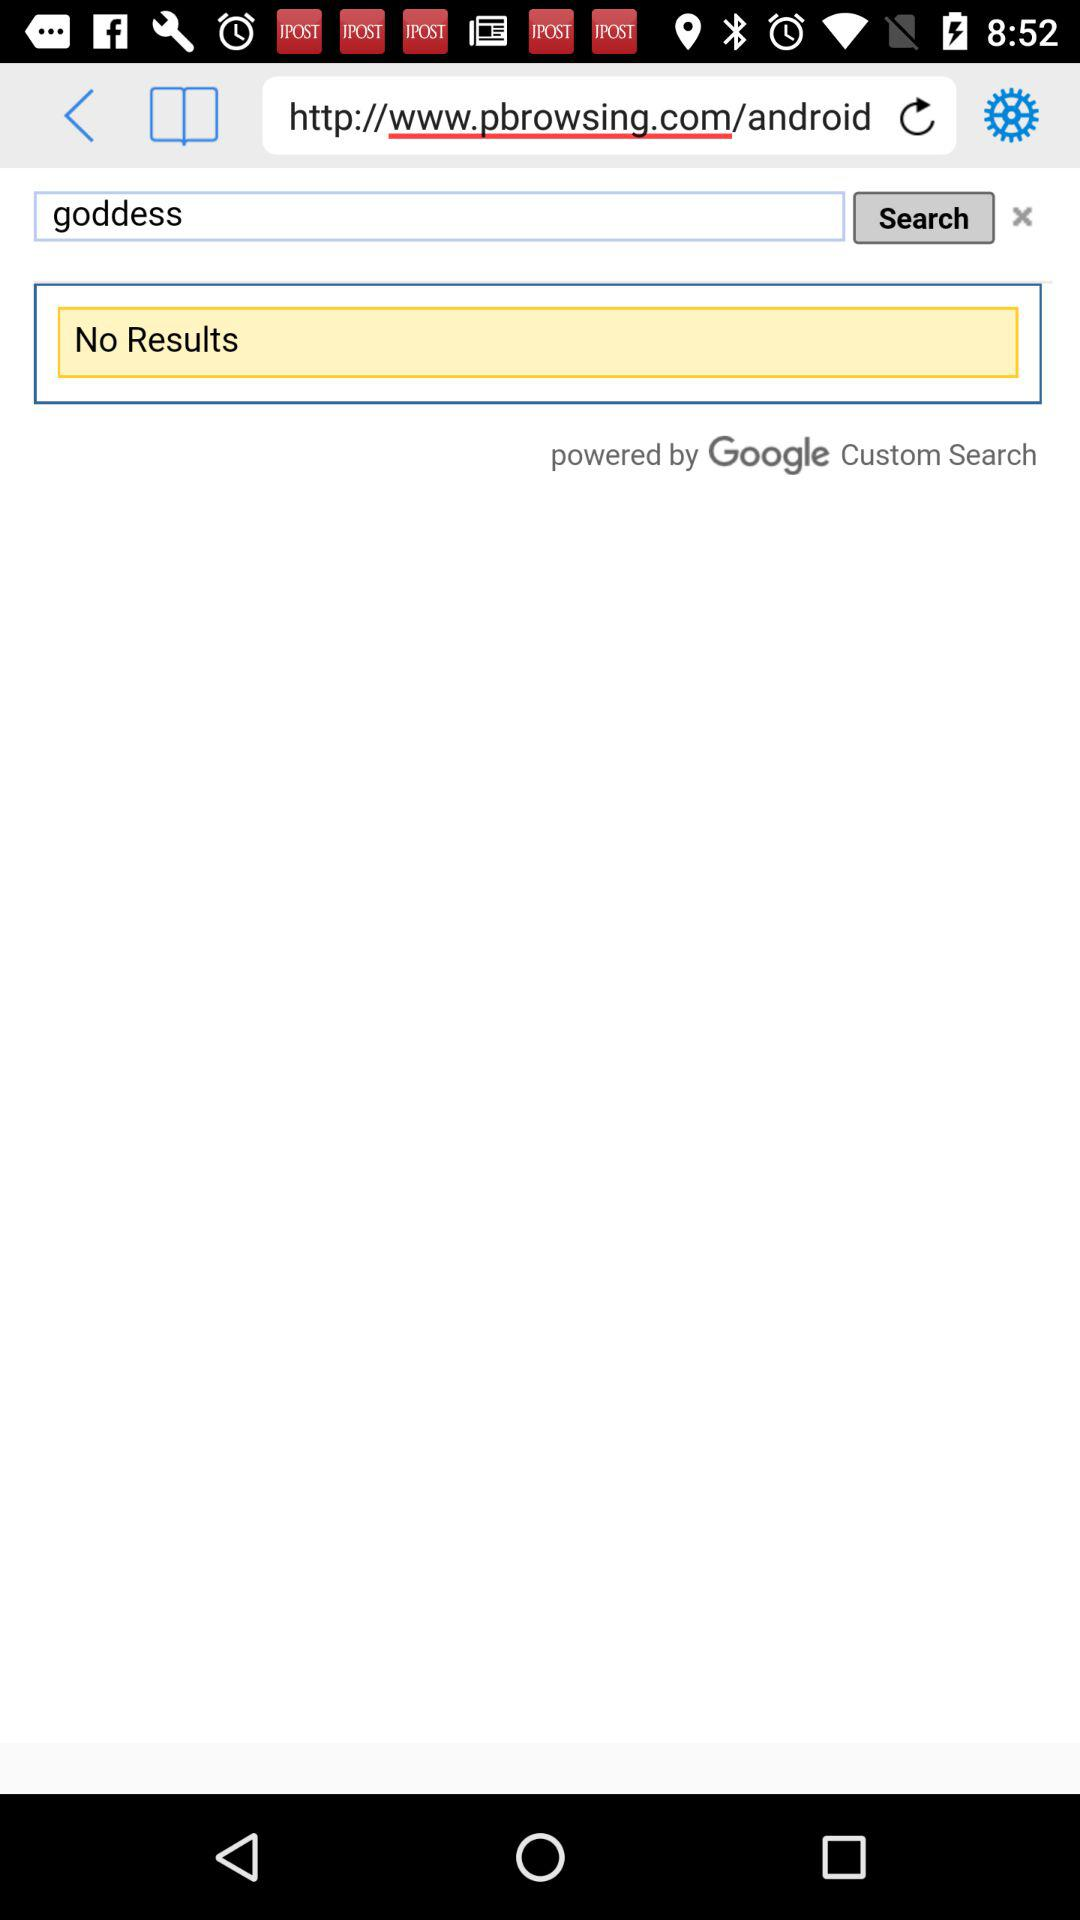It is powered by whom? It is powered by "Google Custom Search". 